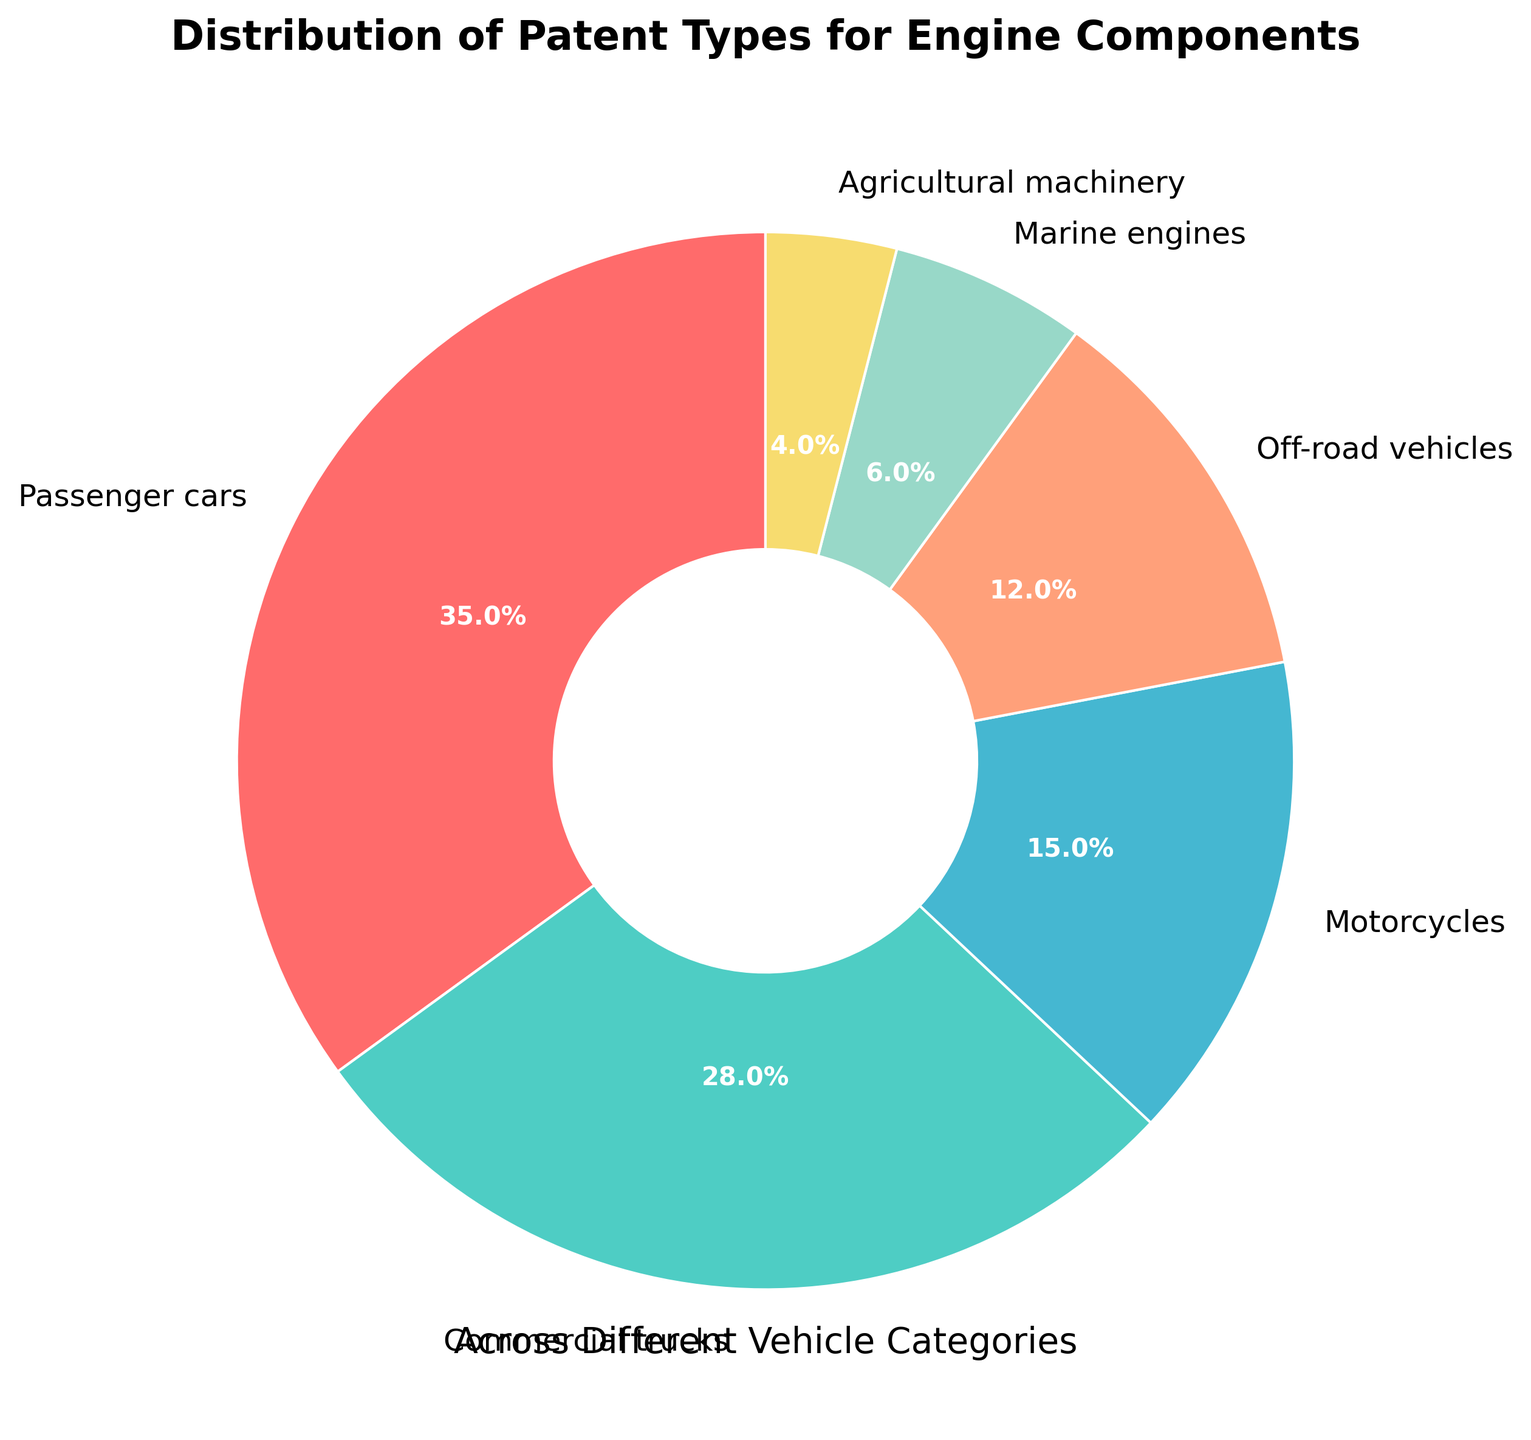What is the percentage of patents for passenger cars? The figure shows that the percentage of patents for passenger cars is clearly labeled at 35%.
Answer: 35% Which vehicle category has the smallest share of patents and what is its percentage? Off-road vehicles with 12%, motorcycles with 15%, and marine engines with 6% are part of the chart. Marine engines have the smallest percentage.
Answer: Marine engines, 6% Which categories together account for more than 50% of the patents? Passenger cars have 35% and commercial trucks have 28%. Together, they account for 35% + 28% = 63%, which is more than 50%.
Answer: Passenger cars and commercial trucks How does the percentage of patents for motorcycles compare to agricultural machinery? Motorcycles have 15% and agricultural machinery has 4%. Comparing these, motorcycles have a higher percentage.
Answer: Motorcycles are higher What is the combined percentage of patents for off-road vehicles and marine engines? Off-road vehicles have 12% and marine engines have 6%. Adding these together, 12% + 6% = 18%.
Answer: 18% Are the patents for commercial trucks closer to the percentage of passenger cars or motorcycles? Commercial trucks have 28%. The difference to passenger cars (35%) is 35% - 28% = 7%, and to motorcycles (15%) is 28% - 15% = 13%. Therefore, it is closer to passenger cars.
Answer: Passenger cars By what percentage do passenger cars lead commercial trucks in terms of patents? Passenger cars have 35% and commercial trucks have 28%. The lead is calculated as 35% - 28% = 7%.
Answer: 7% What is the visual color of the segment representing agricultural machinery? The pie chart segment for agricultural machinery is visually represented in yellow.
Answer: Yellow Which category segment appears largest on the pie chart? The largest segment on the pie chart visually and numerically belongs to passenger cars with 35%.
Answer: Passenger cars What is the combined percentage of patents for categories excluding passenger cars and commercial trucks? Excluding passenger cars (35%) and commercial trucks (28%), the other categories are motorcycles (15%), off-road vehicles (12%), marine engines (6%), and agricultural machinery (4%). Adding these, 15% + 12% + 6% + 4% = 37%.
Answer: 37% 